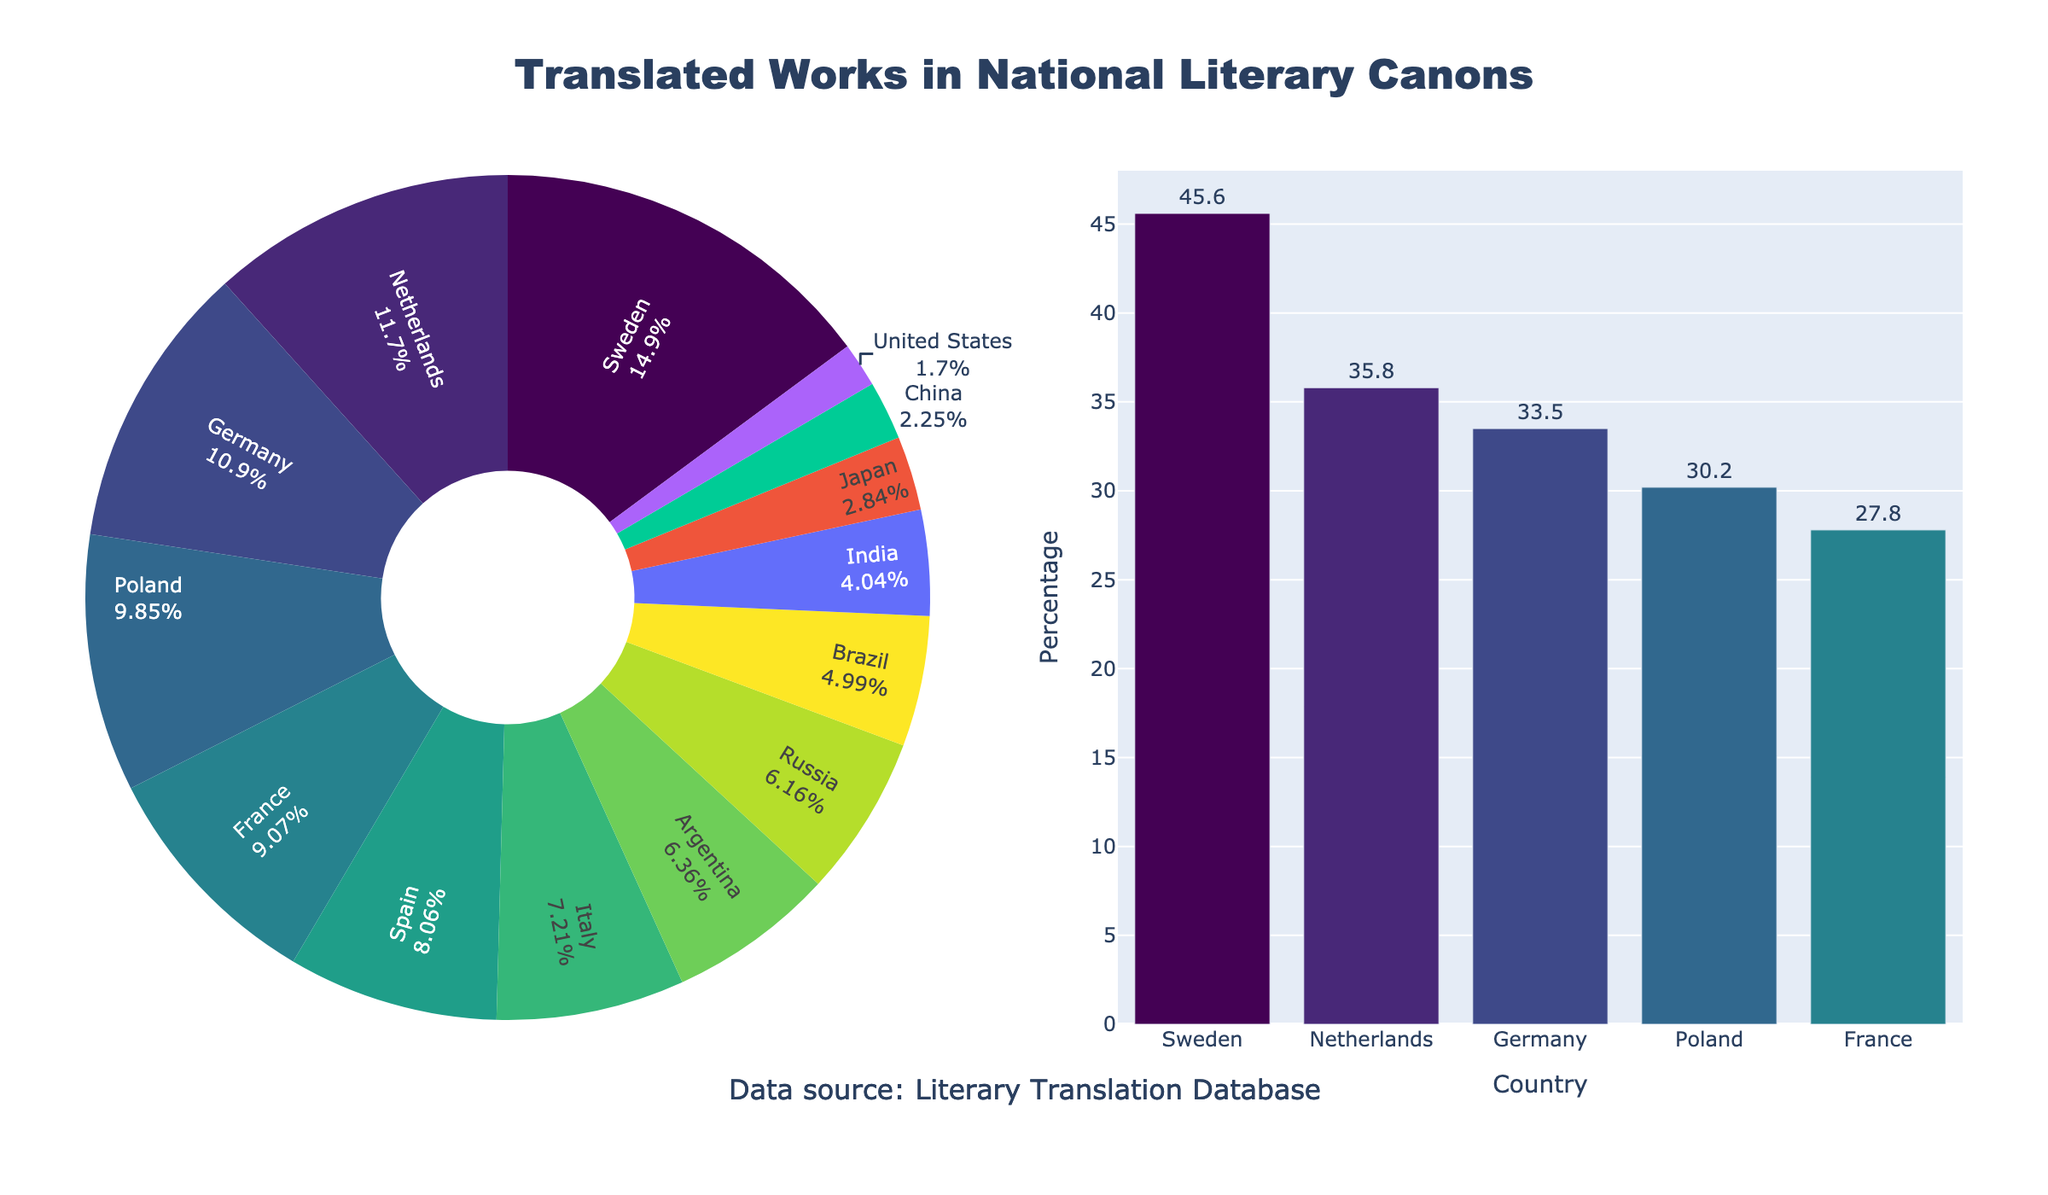Which country has the highest proportion of translated works in its national literary canon? The pie chart shows the proportions, and Sweden has the largest slice, representing the highest proportion.
Answer: Sweden Which country has the lowest proportion of translated works in its national literary canon? The pie chart shows the proportions, and the United States has the smallest slice, representing the lowest proportion.
Answer: United States How much higher is the percentage of translated works in Sweden compared to the United States? Sweden has 45.6%, and the United States has 5.2%. The difference is 45.6% - 5.2% = 40.4%.
Answer: 40.4% What is the average percentage of translated works for the top 5 countries? The top 5 countries and their percentages are: Sweden (45.6%), Netherlands (35.8%), Germany (33.5%), Poland (30.2%), and France (27.8%). The average is (45.6 + 35.8 + 33.5 + 30.2 + 27.8) / 5 = 34.58%.
Answer: 34.58% Which countries have a higher percentage of translated works than France? By observing the pie chart, the countries with a higher percentage than France (27.8%) are Sweden, Netherlands, Germany, and Poland.
Answer: Sweden, Netherlands, Germany, Poland What is the combined percentage of translated works for Germany and France? Germany has 33.5%, and France has 27.8%. The combined percentage is 33.5% + 27.8% = 61.3%.
Answer: 61.3% Which country ranks fifth in the percentage of translated works? By referring to the bar chart that lists the top 5 countries, France is the fifth country.
Answer: France How does Japan's percentage of translated works compare to China's? Japan has 8.7%, and China has 6.9%. Japan has a higher percentage of translated works than China.
Answer: Japan Between Brazil and Argentina, which country has a larger proportion of translated works in its national literary canon? By referring to the pie chart, Argentina has a larger slice than Brazil.
Answer: Argentina 